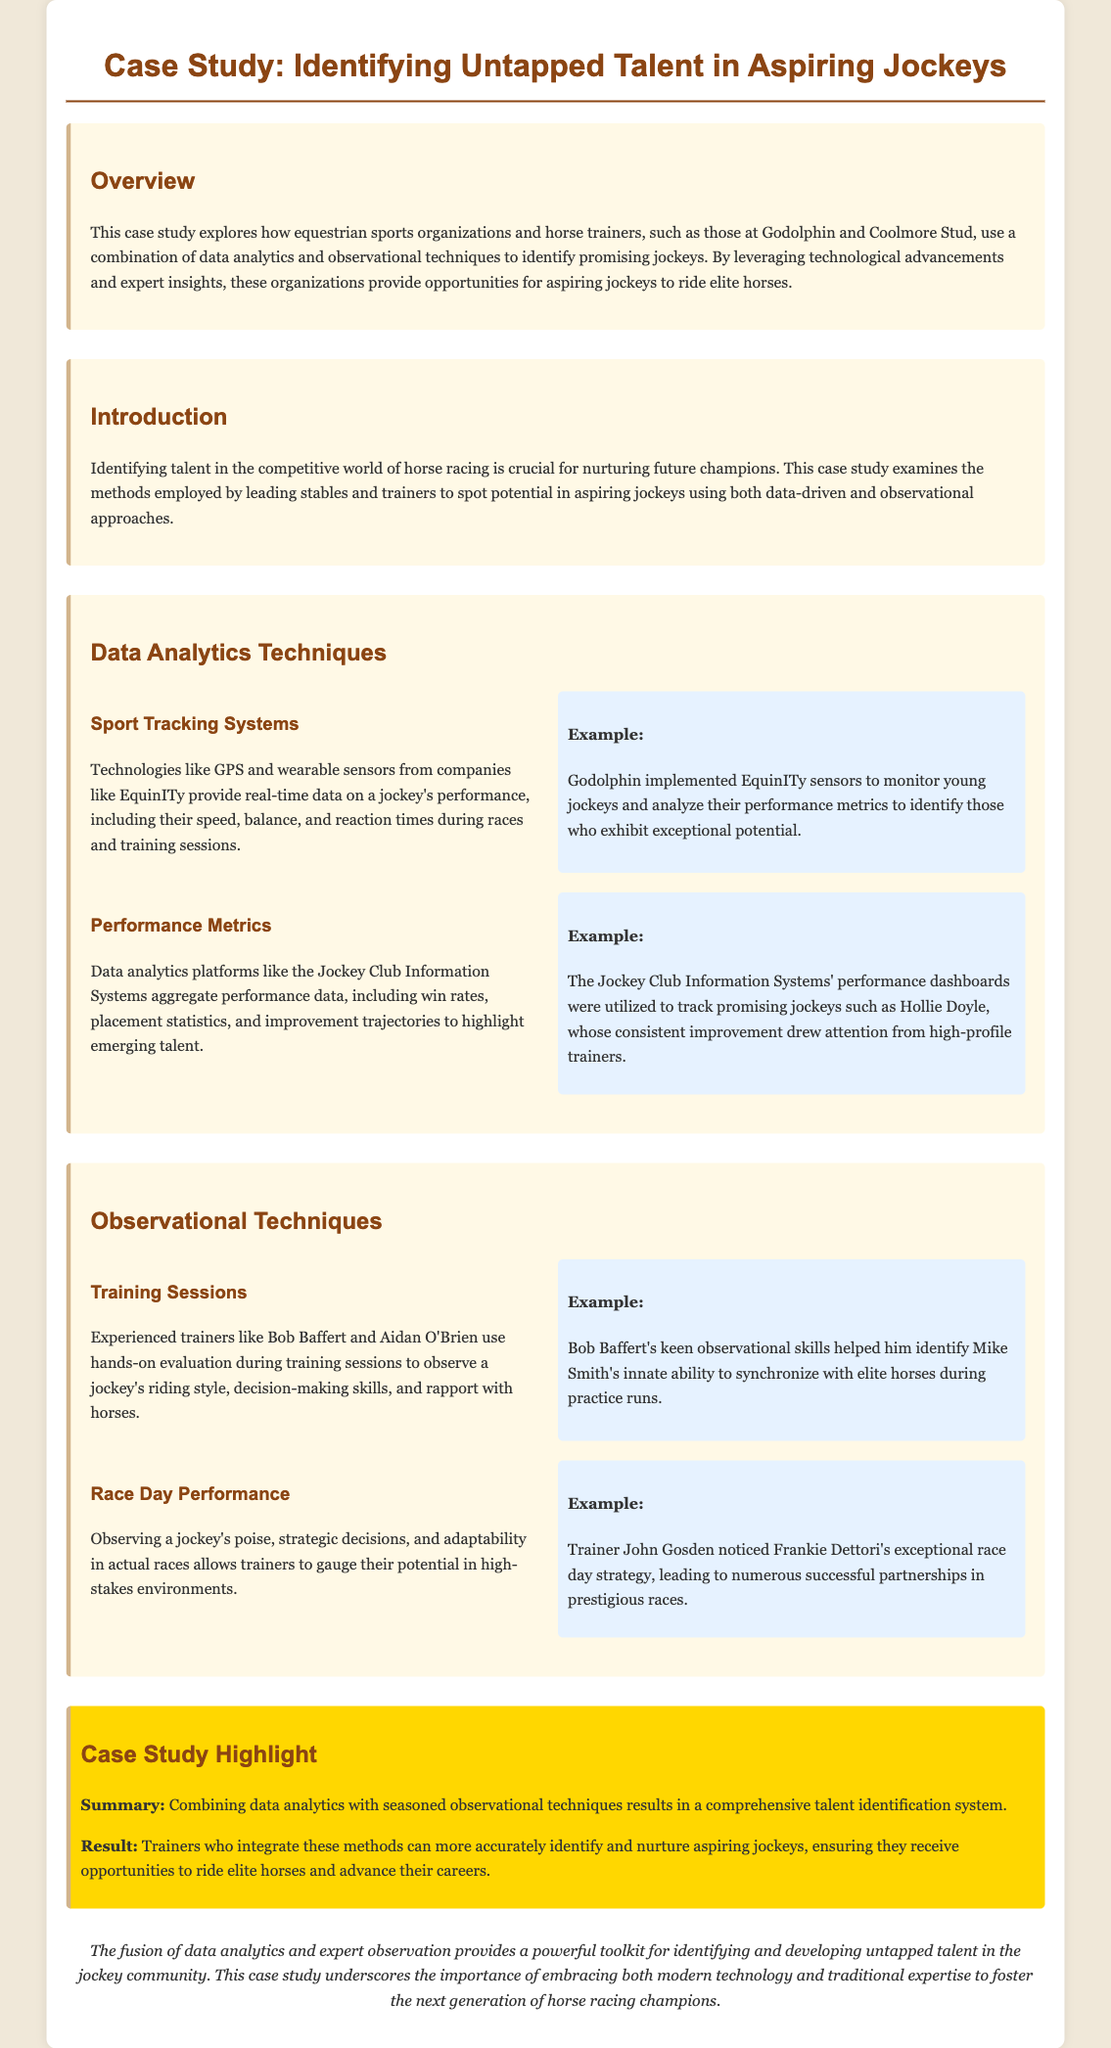what is the title of the case study? The title of the case study is stated at the beginning of the document.
Answer: Identifying Untapped Talent in Aspiring Jockeys which organizations are mentioned in the overview? The overview mentions two specific organizations in the context of the study.
Answer: Godolphin and Coolmore Stud what technology provides real-time data on jockeys? The document specifies a technology used to track jockey performance.
Answer: GPS and wearable sensors who is an example of a promising jockey tracked by performance metrics? The performance metrics section mentions a specific jockey as an example.
Answer: Hollie Doyle what observational technique involves hands-on evaluation? The observational techniques section describes a specific technique used by trainers.
Answer: Training Sessions who helped identify Mike Smith's abilities? The case study provides a name of a trainer associated with recognizing Mike Smith's talent.
Answer: Bob Baffert what is the result of combining data analytics with observational techniques? The highlight section summarizes the outcome of combining the two methods.
Answer: A comprehensive talent identification system who is noted for exceptional race day strategy? The document names a jockey associated with exceptional performance on race days.
Answer: Frankie Dettori 